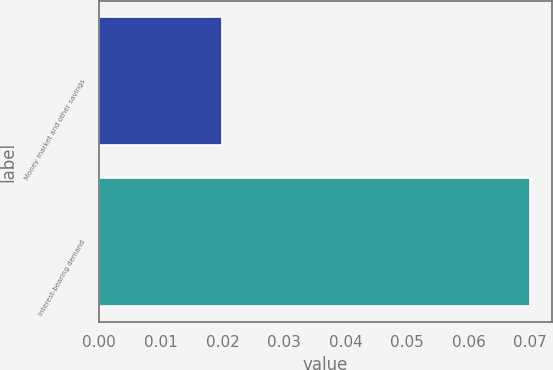<chart> <loc_0><loc_0><loc_500><loc_500><bar_chart><fcel>Money market and other savings<fcel>Interest-bearing demand<nl><fcel>0.02<fcel>0.07<nl></chart> 